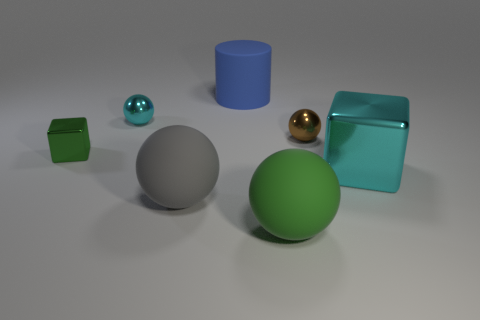Are there an equal number of gray rubber things that are on the right side of the large block and tiny things?
Your answer should be very brief. No. What number of small things are either brown things or green metallic spheres?
Ensure brevity in your answer.  1. What shape is the small metallic thing that is the same color as the big cube?
Provide a succinct answer. Sphere. Does the cyan thing in front of the brown metal thing have the same material as the small block?
Your answer should be very brief. Yes. There is a cube that is to the right of the tiny metal thing that is behind the brown object; what is it made of?
Make the answer very short. Metal. How many other metal things are the same shape as the large blue object?
Make the answer very short. 0. There is a block that is right of the tiny metallic thing that is left of the cyan metallic object that is to the left of the blue rubber cylinder; what size is it?
Offer a terse response. Large. What number of brown objects are metal objects or large shiny objects?
Your response must be concise. 1. Do the tiny object that is right of the big blue rubber thing and the big gray object have the same shape?
Ensure brevity in your answer.  Yes. Are there more objects in front of the large metallic block than small red spheres?
Your answer should be very brief. Yes. 